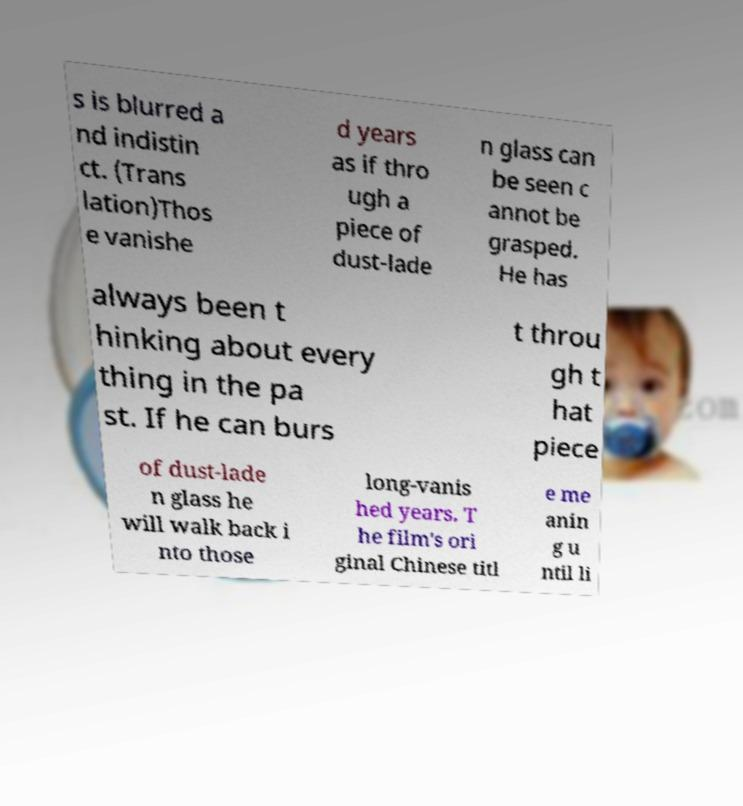Can you read and provide the text displayed in the image?This photo seems to have some interesting text. Can you extract and type it out for me? s is blurred a nd indistin ct. (Trans lation)Thos e vanishe d years as if thro ugh a piece of dust-lade n glass can be seen c annot be grasped. He has always been t hinking about every thing in the pa st. If he can burs t throu gh t hat piece of dust-lade n glass he will walk back i nto those long-vanis hed years. T he film's ori ginal Chinese titl e me anin g u ntil li 